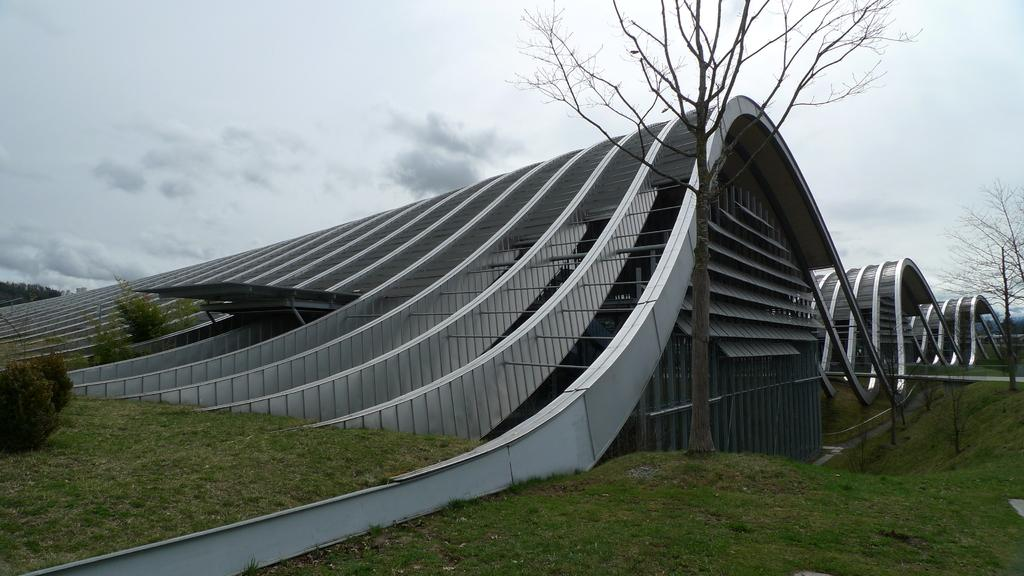What type of building is in the center of the image? There is a museum in the center of the image. What is located at the bottom of the image? There is grass at the bottom of the image. What type of vegetation can be seen in the image? There are trees and plants in the image. What is visible at the top of the image? The sky is visible at the top of the image. What type of feather can be seen on the museum's roof in the image? There is no feather visible on the museum's roof in the image. What activity is taking place in the museum in the image? The image does not show any activity taking place inside the museum, so it cannot be determined from the image. 